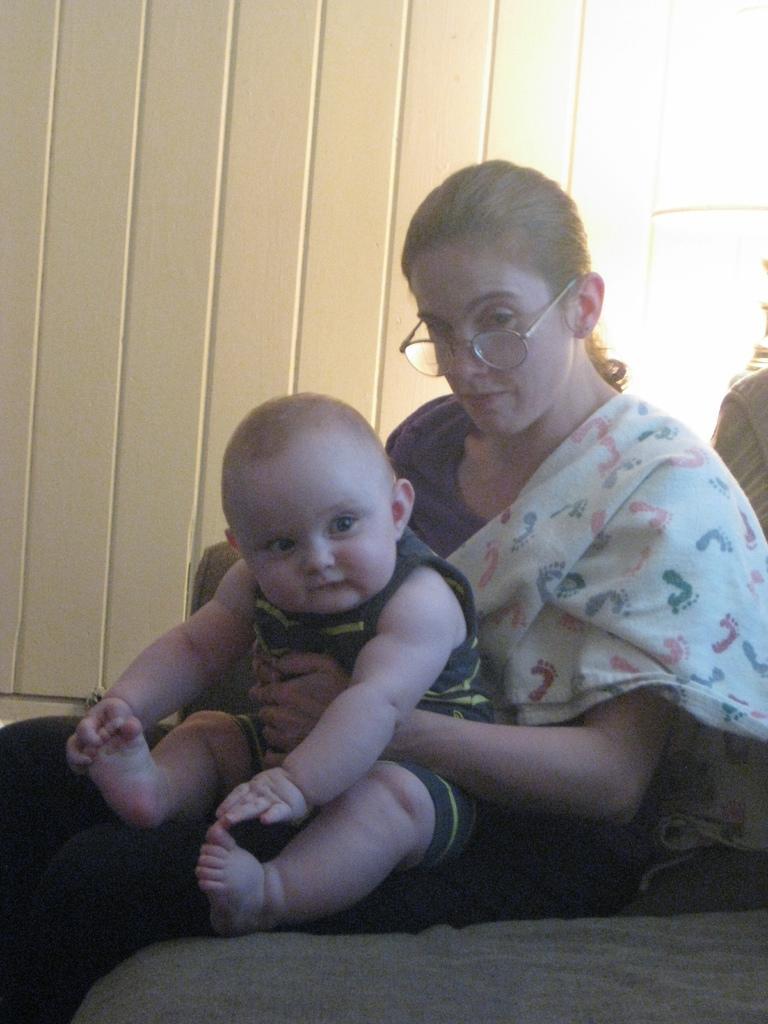Please provide a concise description of this image. In the foreground of this image, there is a woman sitting on a grey surface holding a baby on her laps. In the background, there is a white wall. 